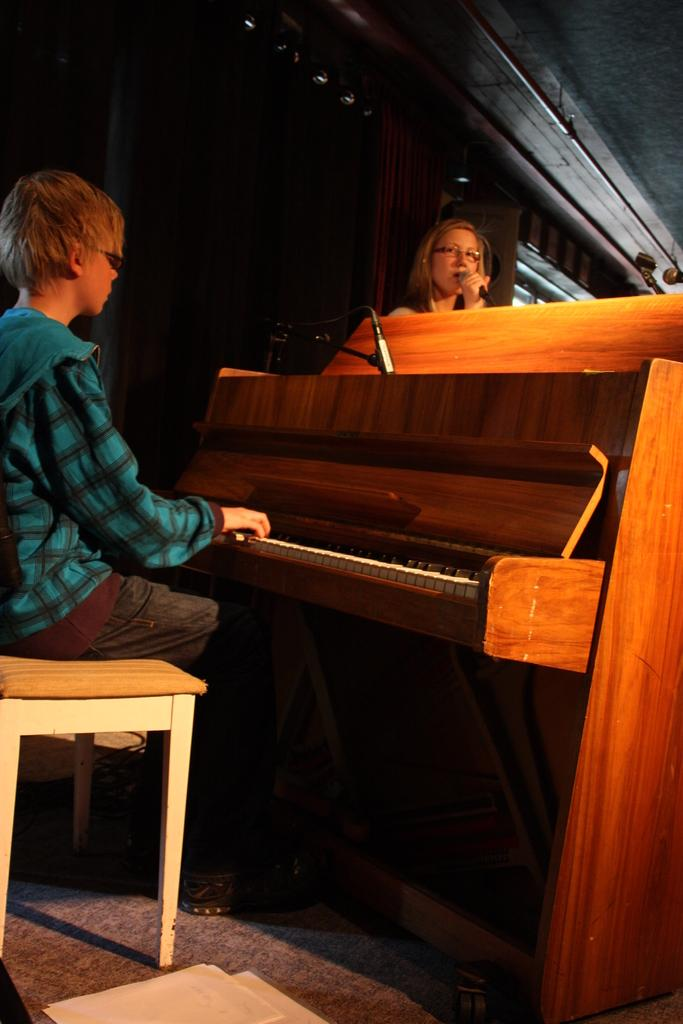What is the person in the image doing? The person is sitting and playing the piano in the image. Who is standing near the piano? There is a woman standing in front of the piano. What is the woman doing? The woman is singing. What object is the woman holding in her hand? The woman is holding a microphone in her hand. Where is the faucet located in the image? There is no faucet present in the image. What type of muscle is being exercised by the person playing the piano? The image does not show any muscles being exercised, as it focuses on the person playing the piano and the woman singing. 